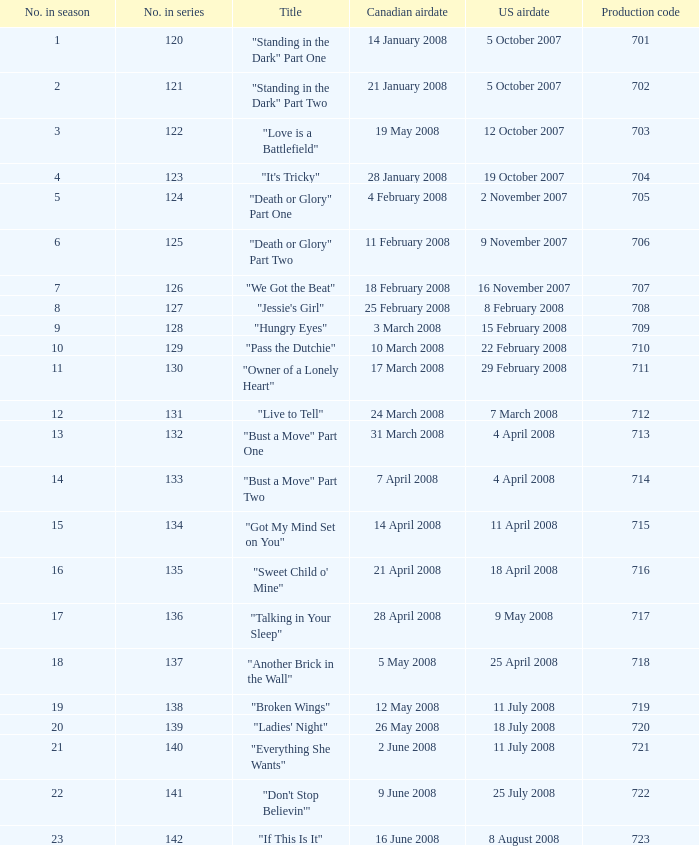The canadian airdate of 17 march 2008 had how many numbers in the season? 1.0. 